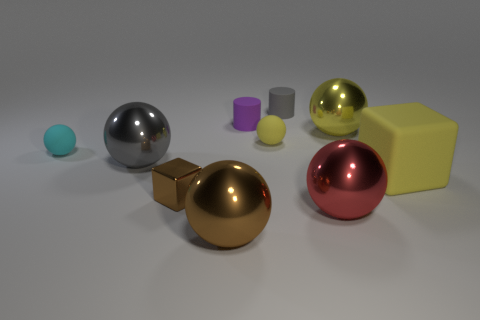Subtract all yellow spheres. How many spheres are left? 4 Subtract 3 balls. How many balls are left? 3 Subtract all green cubes. How many yellow spheres are left? 2 Subtract all gray balls. How many balls are left? 5 Subtract all cylinders. How many objects are left? 8 Subtract all red spheres. Subtract all green cylinders. How many spheres are left? 5 Subtract all yellow metallic spheres. Subtract all tiny gray matte blocks. How many objects are left? 9 Add 6 small shiny cubes. How many small shiny cubes are left? 7 Add 8 tiny blue matte spheres. How many tiny blue matte spheres exist? 8 Subtract 0 green spheres. How many objects are left? 10 